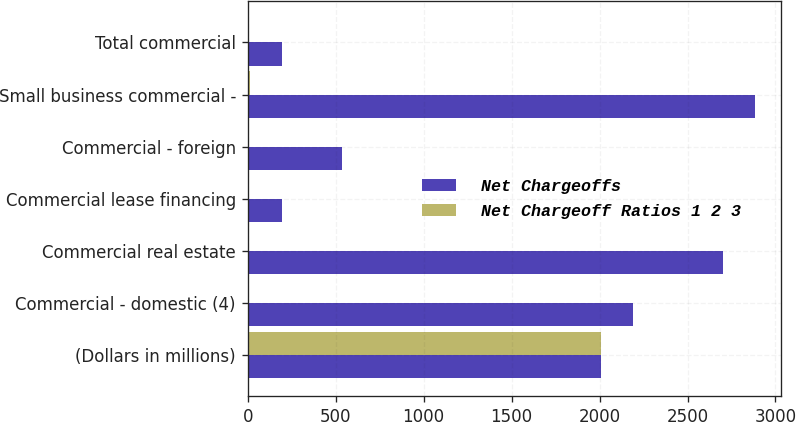Convert chart. <chart><loc_0><loc_0><loc_500><loc_500><stacked_bar_chart><ecel><fcel>(Dollars in millions)<fcel>Commercial - domestic (4)<fcel>Commercial real estate<fcel>Commercial lease financing<fcel>Commercial - foreign<fcel>Small business commercial -<fcel>Total commercial<nl><fcel>Net Chargeoffs<fcel>2009<fcel>2190<fcel>2702<fcel>195<fcel>537<fcel>2886<fcel>195<nl><fcel>Net Chargeoff Ratios 1 2 3<fcel>2009<fcel>1.09<fcel>3.69<fcel>0.89<fcel>1.76<fcel>15.68<fcel>2.47<nl></chart> 